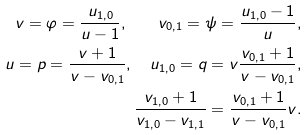Convert formula to latex. <formula><loc_0><loc_0><loc_500><loc_500>v = \varphi = \frac { u _ { 1 , 0 } } { u - 1 } , \quad v _ { 0 , 1 } = \psi = \frac { u _ { 1 , 0 } - 1 } { u } , \\ u = p = \frac { v + 1 } { v - v _ { 0 , 1 } } , \quad u _ { 1 , 0 } = q = v \frac { v _ { 0 , 1 } + 1 } { v - v _ { 0 , 1 } } , \\ \frac { v _ { 1 , 0 } + 1 } { v _ { 1 , 0 } - v _ { 1 , 1 } } = \frac { v _ { 0 , 1 } + 1 } { v - v _ { 0 , 1 } } v .</formula> 